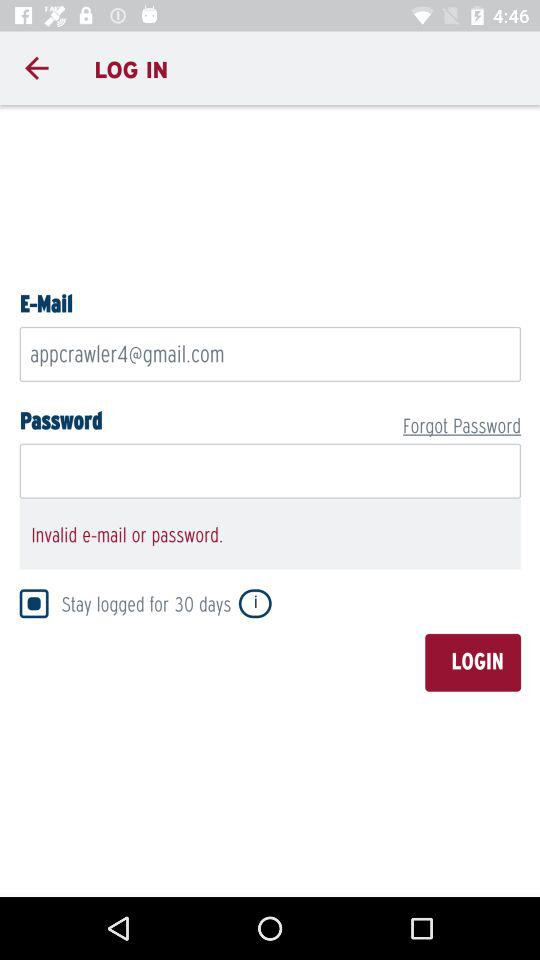What is the email address? The email address is appcrawler4@gmail.com. 